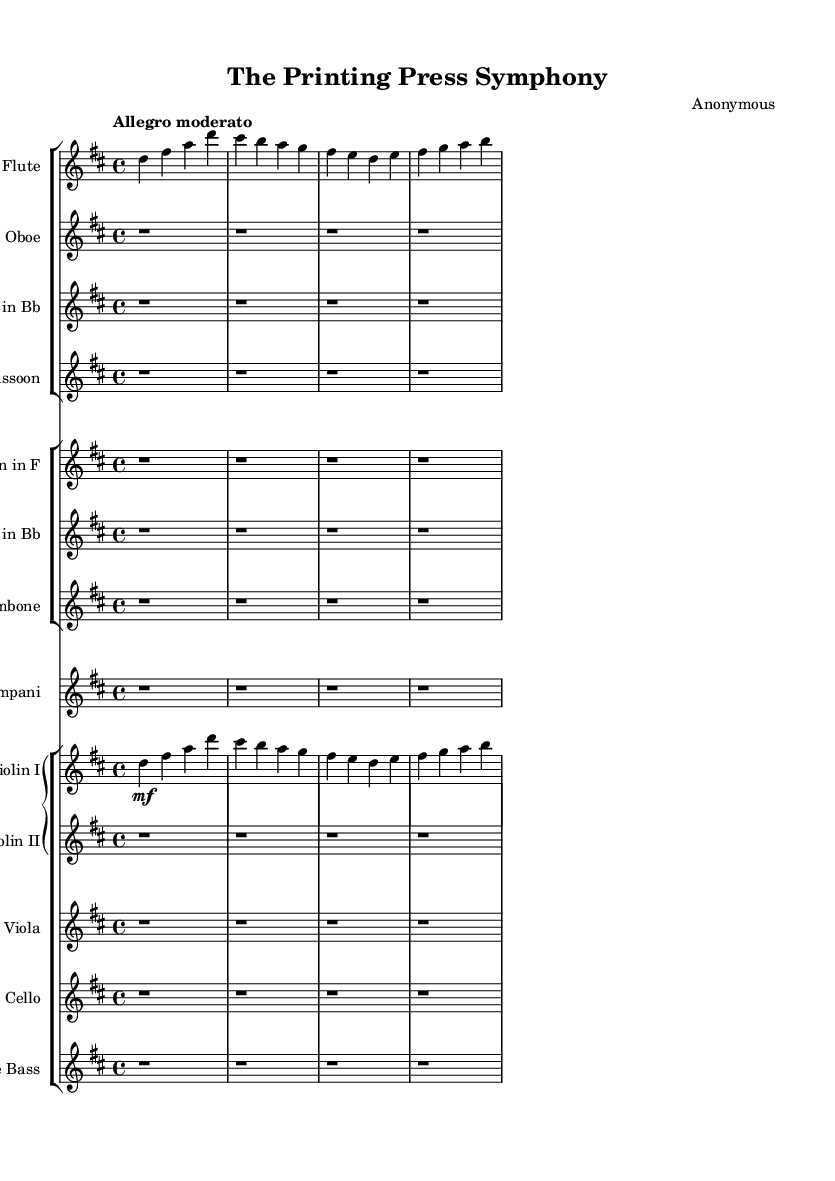What is the key signature of this music? The key signature is D major, which has two sharps (F# and C#). This can be determined by looking at the key signature section at the beginning of the music.
Answer: D major What is the time signature of this composition? The time signature is 4/4, which indicates four beats per measure. This is evident from the time signature notation present at the start of the score.
Answer: 4/4 What is the tempo marking for this piece? The tempo marking is "Allegro moderato". This is explicitly stated at the beginning of the score, indicating a moderately fast pace.
Answer: Allegro moderato How many instruments are featured in this orchestral piece? This composition features a total of 12 instruments, which can be identified by counting the separate staves in the score.
Answer: 12 Which instruments are providing harmonies in the first section? The flute and violin I are providing harmonies in the first section by playing together melodic lines that complement each other. This can be inferred from their simultaneous entries and note values in the score.
Answer: Flute and Violin I What is the dynamic marking for the flute in the first measure? The dynamic marking for the flute in the first measure is "mf", meaning moderately loud. This is indicated by the dynamic marking placed directly below the flute staff.
Answer: mf Which section of the orchestra has the rest values represented throughout the score? The woodwind section has the rest values represented throughout the score, as indicated by the measures filled with rest notations for the oboe, clarinet, bassoon, and horn.
Answer: Woodwinds 